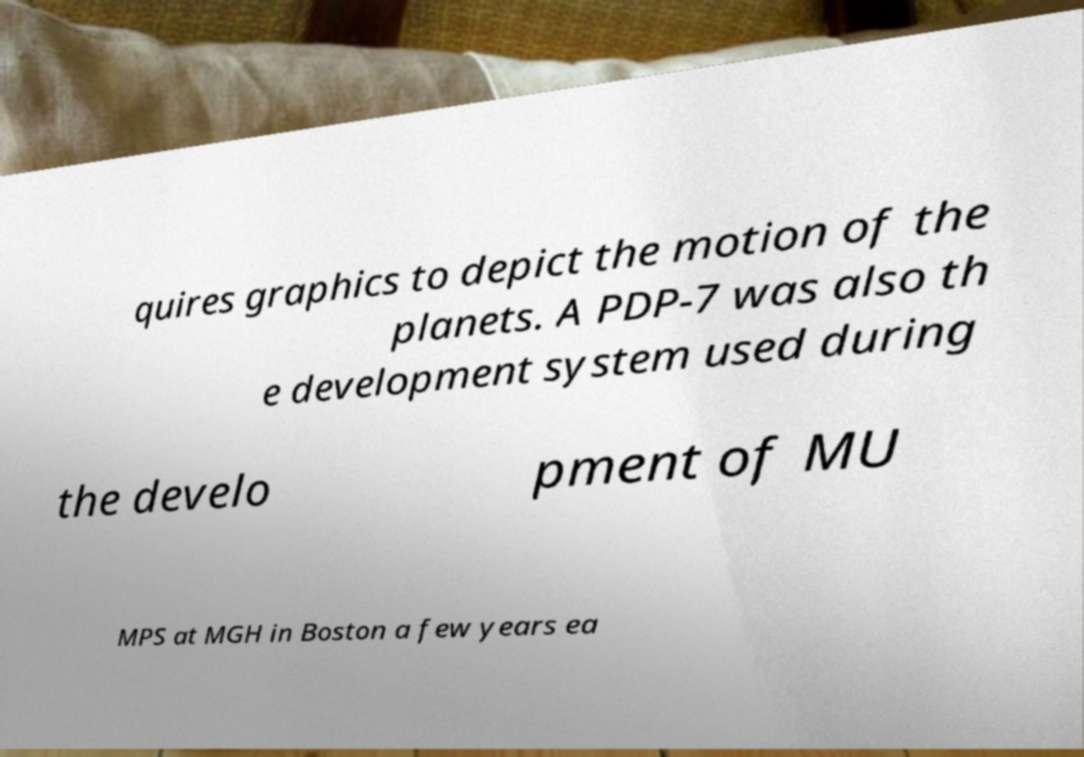Please identify and transcribe the text found in this image. quires graphics to depict the motion of the planets. A PDP-7 was also th e development system used during the develo pment of MU MPS at MGH in Boston a few years ea 